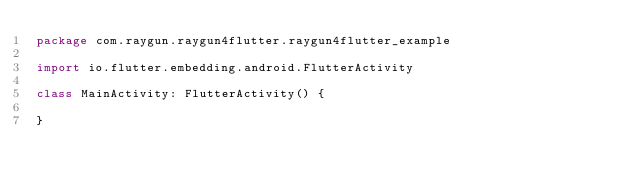<code> <loc_0><loc_0><loc_500><loc_500><_Kotlin_>package com.raygun.raygun4flutter.raygun4flutter_example

import io.flutter.embedding.android.FlutterActivity

class MainActivity: FlutterActivity() {

}
</code> 